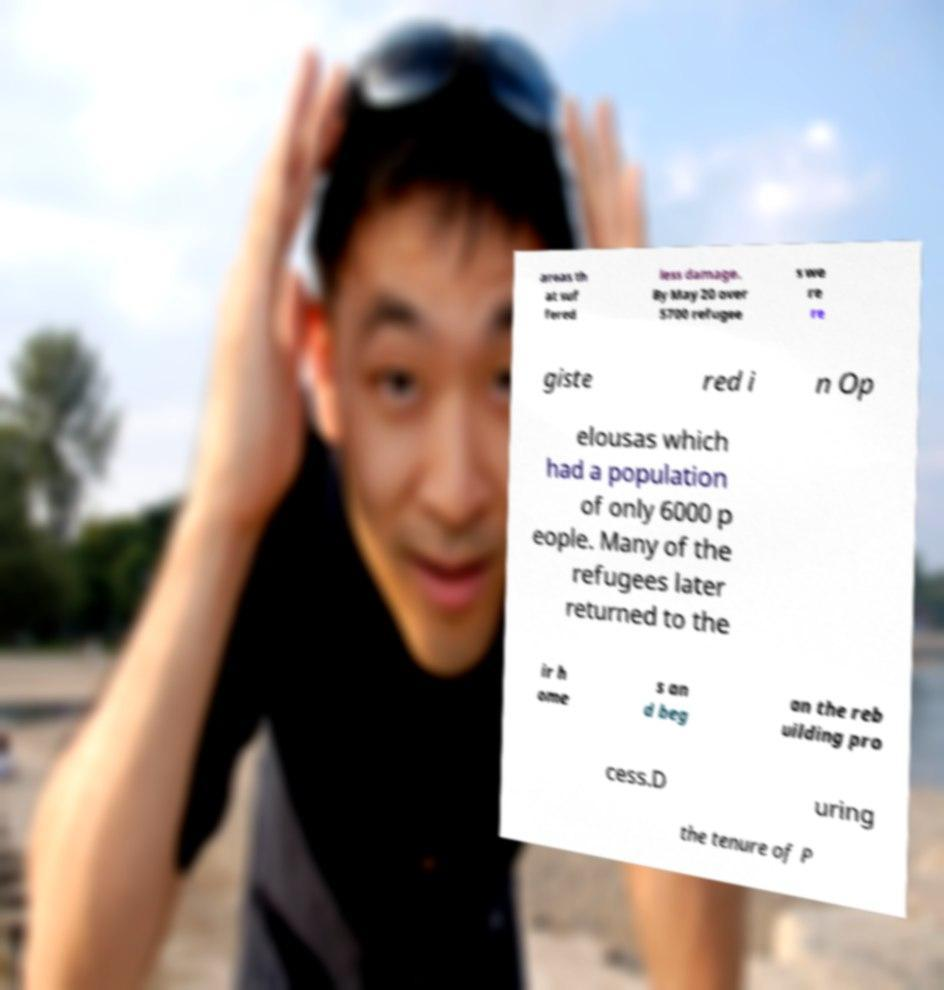Can you read and provide the text displayed in the image?This photo seems to have some interesting text. Can you extract and type it out for me? areas th at suf fered less damage. By May 20 over 5700 refugee s we re re giste red i n Op elousas which had a population of only 6000 p eople. Many of the refugees later returned to the ir h ome s an d beg an the reb uilding pro cess.D uring the tenure of P 